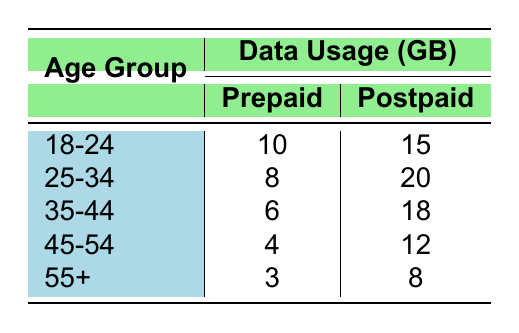What is the data usage for the age group 25-34 on a prepaid plan? The table indicates the data usage for the age group 25-34 under the prepaid plan is listed as 8 GB in the respective row.
Answer: 8 GB Which service plan has higher data usage for the age group 18-24? By inspecting the values in the table for the age group 18-24, the prepaid plan uses 10 GB, while the postpaid plan uses 15 GB. Since 15 GB is greater than 10 GB, the postpaid plan has higher data usage.
Answer: Postpaid What is the total data usage for prepaid plans across all age groups? To find the total data usage for prepaid plans, we add the values from the prepaid column: 10 + 8 + 6 + 4 + 3 = 31 GB.
Answer: 31 GB Is the data usage for the age group 55+ higher on prepaid than on postpaid? The table shows that for the age group 55+, the prepaid data usage is 3 GB and the postpaid is 8 GB. Since 3 GB is less than 8 GB, the statement is false.
Answer: No What is the difference in data usage between postpaid and prepaid for the age group 35-44? The postpaid data usage for the age group 35-44 is 18 GB and the prepaid usage is 6 GB. The difference is calculated by subtracting the prepaid value from the postpaid value: 18 - 6 = 12 GB.
Answer: 12 GB Which age group has the lowest data usage for prepaid plans? Looking through the prepaid column, the lowest usage is in the age group 55+, which has 3 GB.
Answer: 55+ What is the average data usage for postpaid plans across all age groups? The postpaid data usage values are 15, 20, 18, 12, and 8 GB. Summing these gives 15 + 20 + 18 + 12 + 8 = 73 GB. There are 5 age groups, so the average is 73/5 = 14.6 GB.
Answer: 14.6 GB Is there an age group that uses more data on prepaid than on postpaid? Upon examining the table data, we find that in all age groups, the prepaid data usage is always less than or equal to the postpaid data usage. Therefore, no age group uses more data on prepaid than on postpaid.
Answer: No 